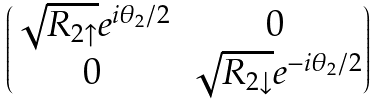Convert formula to latex. <formula><loc_0><loc_0><loc_500><loc_500>\begin{pmatrix} \sqrt { R _ { 2 \uparrow } } e ^ { i \theta _ { 2 } / 2 } & 0 \\ 0 & \sqrt { R _ { 2 \downarrow } } e ^ { - i \theta _ { 2 } / 2 } \\ \end{pmatrix}</formula> 